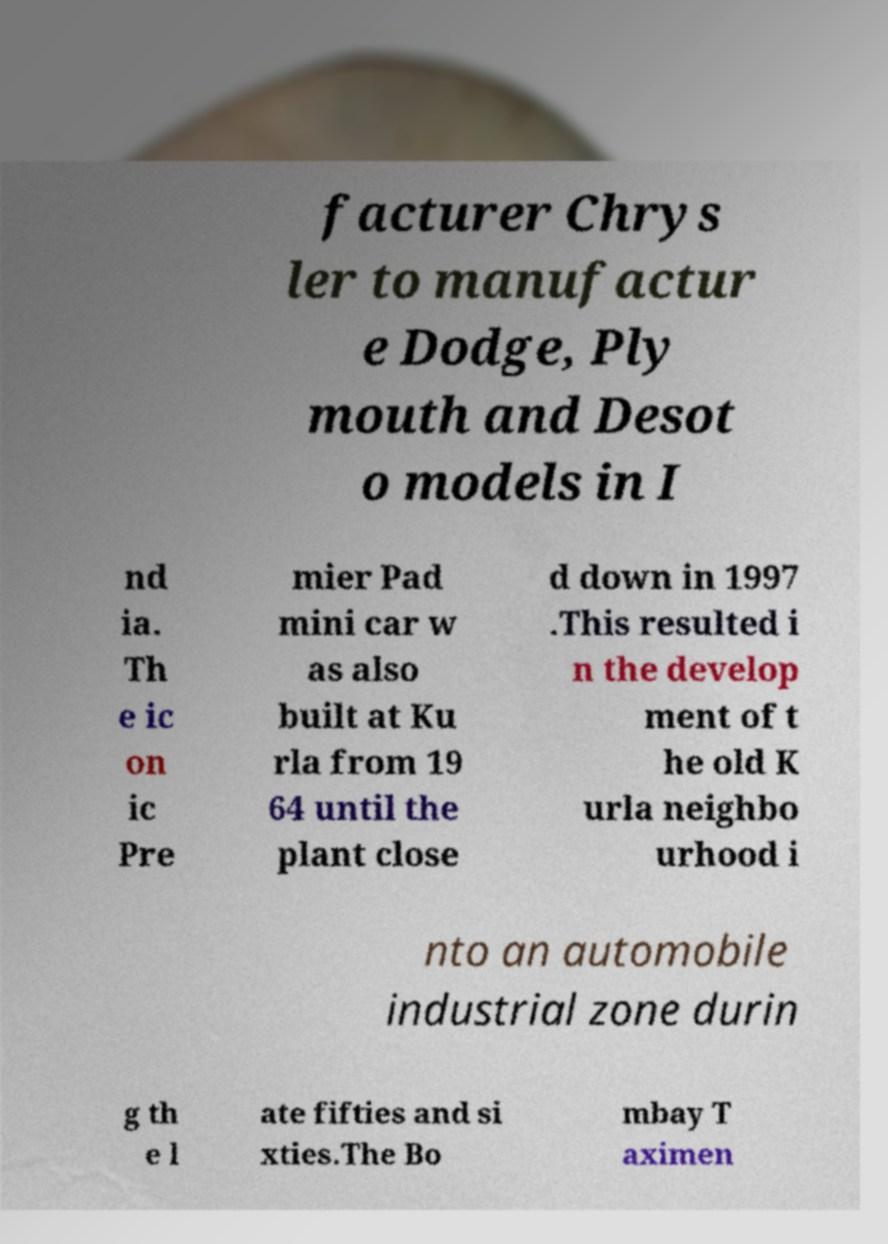There's text embedded in this image that I need extracted. Can you transcribe it verbatim? facturer Chrys ler to manufactur e Dodge, Ply mouth and Desot o models in I nd ia. Th e ic on ic Pre mier Pad mini car w as also built at Ku rla from 19 64 until the plant close d down in 1997 .This resulted i n the develop ment of t he old K urla neighbo urhood i nto an automobile industrial zone durin g th e l ate fifties and si xties.The Bo mbay T aximen 